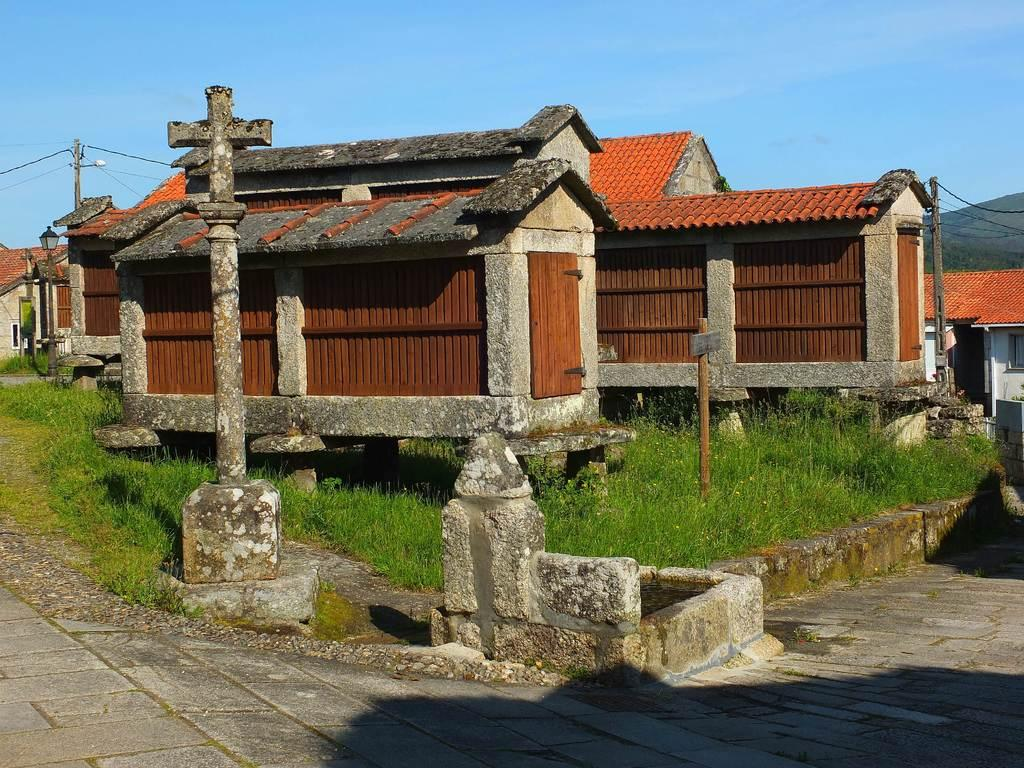What type of structures can be seen in the image? There are houses in the image. What architectural features are present in the image? Walls, doors, pillars, and poles are visible in the image. What is the purpose of the street light in the image? The street light is present to provide illumination. What type of vegetation can be seen in the image? Grass is visible in the image. What is at the bottom of the image? There is a walkway at the bottom of the image. What can be seen in the background of the image? The sky, hills, and wires are visible in the background of the image. What type of health issues are the houses in the image experiencing? There is no information about the health of the houses in the image. What type of comb is being used to style the pillars in the image? There is no comb present in the image, and the pillars are not being styled. 